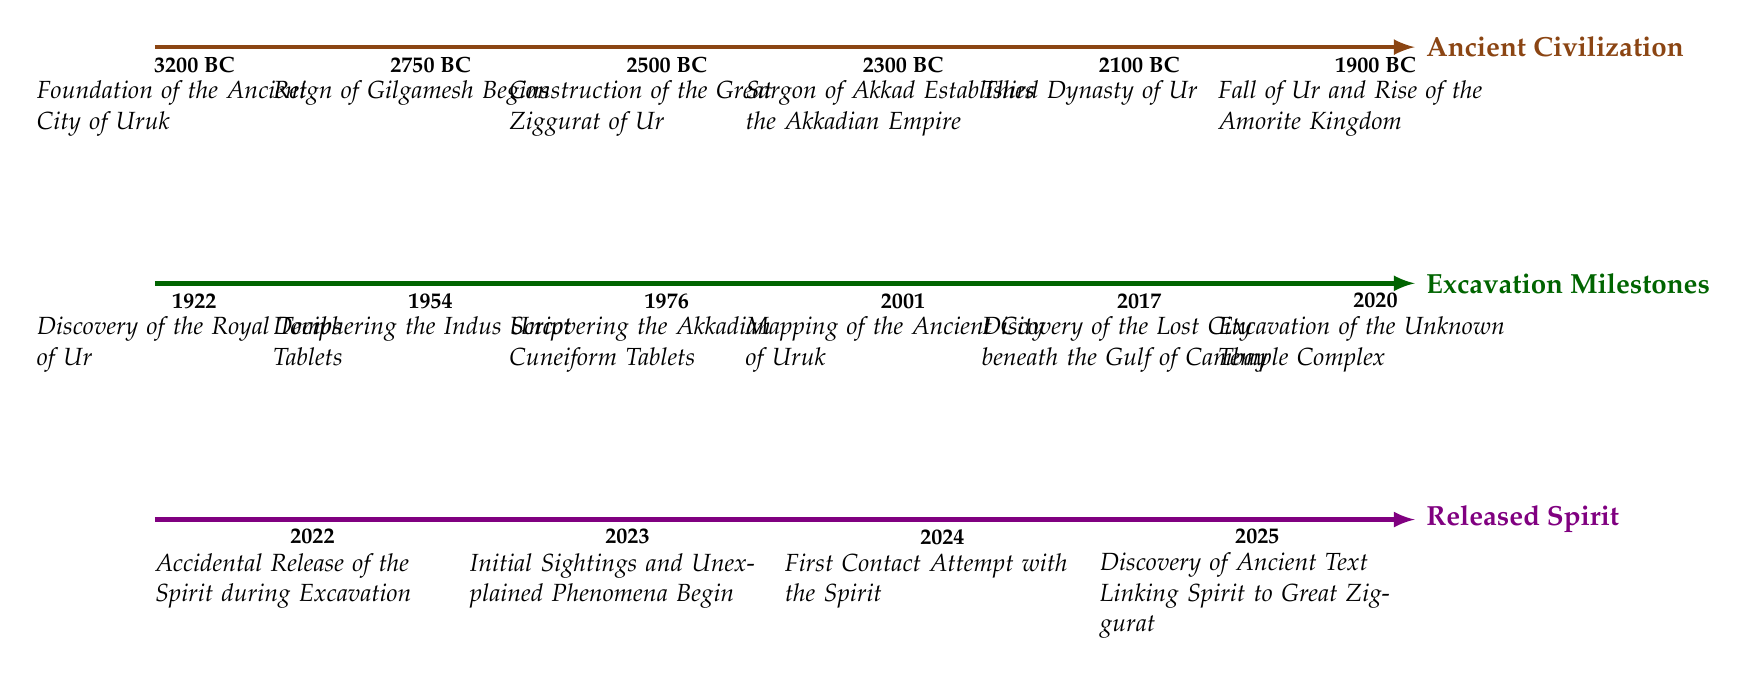What is the year of the foundation of the Ancient City of Uruk? The diagram lists the foundation of the Ancient City of Uruk as occurring in 3200 BC, which is indicated by a year node on the timeline labeled "3200 BC."
Answer: 3200 BC How many key events are listed under the Ancient Civilization timeline? Upon reviewing the Ancient Civilization timeline, we can count six distinct events each marked with a year through the timeline.
Answer: 6 What significant event happened in 1954? The diagram displays that in 1954, the deciphering of the Indus Script Tablets was achieved, marked by a year node labeled "1954."
Answer: Deciphering the Indus Script Tablets In what year did the accidental release of the spirit occur? According to the diagram, the accidental release of the spirit took place in 2022, as indicated by a year node labeled "2022" on the Released Spirit timeline.
Answer: 2022 What discovery was made in 2025 related to the spirit? The diagram notes that in 2025, a discovery was made of an ancient text linking the spirit to the Great Ziggurat, indicated by a year node labeled "2025."
Answer: Discovery of Ancient Text Linking Spirit to Great Ziggurat What is the relationship between the fall of Ur and the rise of the Amorite Kingdom? The relationship can be understood through the timeline, where the fall of Ur in 1900 BC leads to the rise of the Amorite Kingdom as indicated by the sequence of events.
Answer: Fall of Ur leads to the Rise of the Amorite Kingdom In which year was the first contact attempt with the spirit made? The diagram states that the first contact attempt with the spirit occurred in 2024, which is indicated by the year node labeled "2024."
Answer: 2024 Which event connects the Ancient Civilization and the Released Spirit timelines? The event that connects both timelines is the discovery of the Great Ziggurat of Ur in 2500 BC and the subsequent relevance of that structure to the spirit, as indicated by the event in 2025.
Answer: Discovery of the Great Ziggurat of Ur How many years passed between the release of the spirit and the first contact attempt with it? By analyzing the years given on the Released Spirit timeline, the spirit was released in 2022, and the first contact attempt was in 2024, so two years passed between these events.
Answer: 2 years 